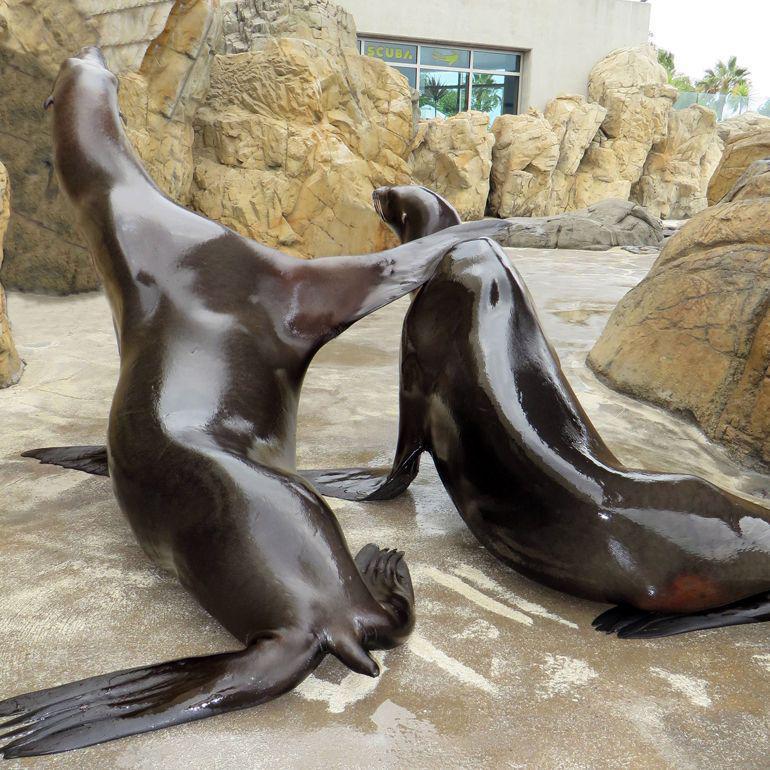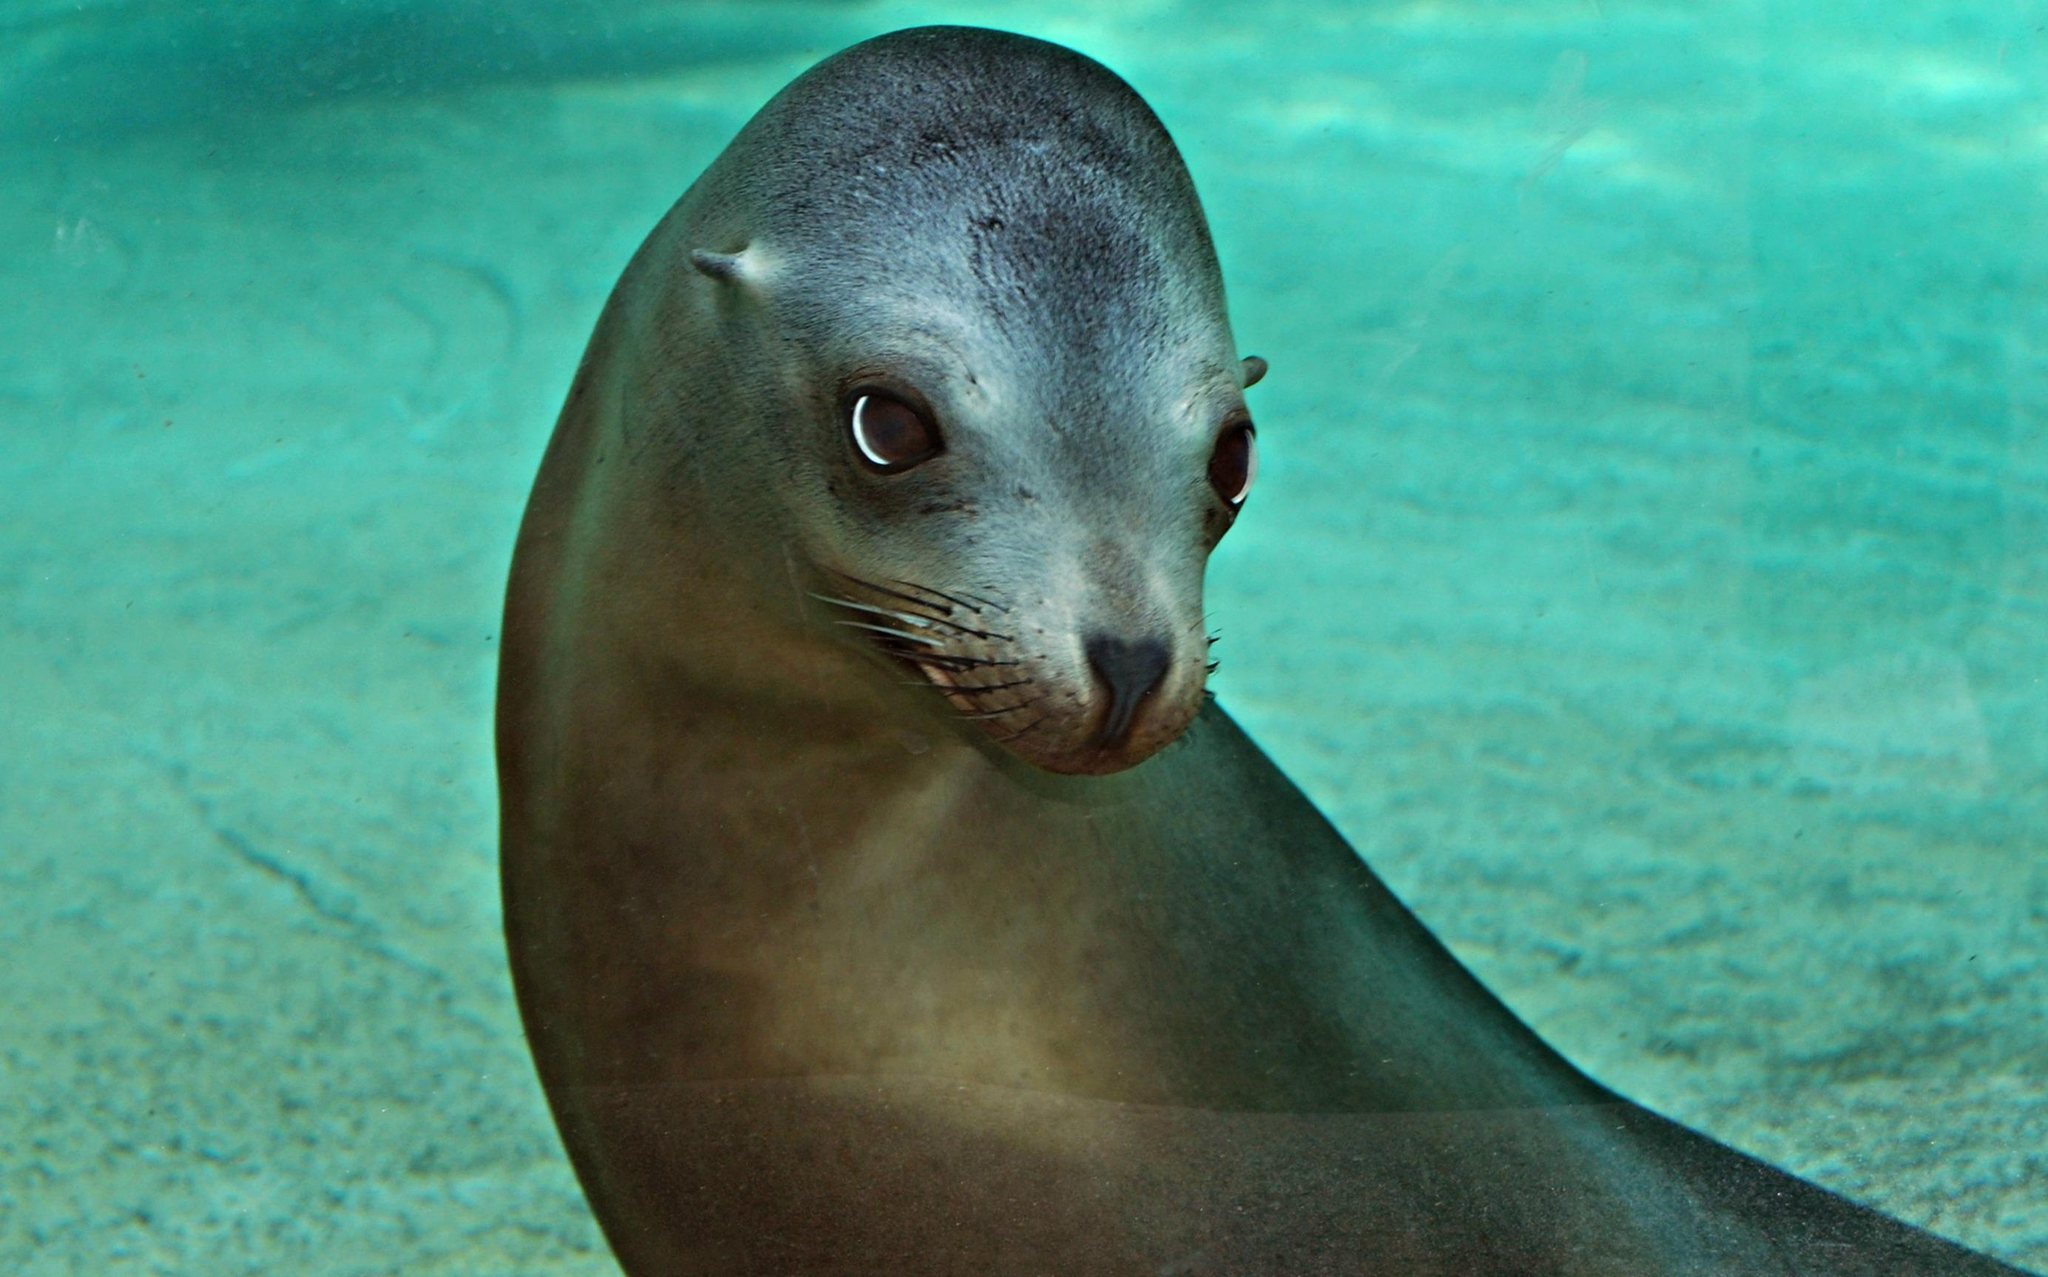The first image is the image on the left, the second image is the image on the right. Considering the images on both sides, is "The right image has a plain white background." valid? Answer yes or no. No. The first image is the image on the left, the second image is the image on the right. Analyze the images presented: Is the assertion "There are only two seals and both are looking in different directions." valid? Answer yes or no. No. 